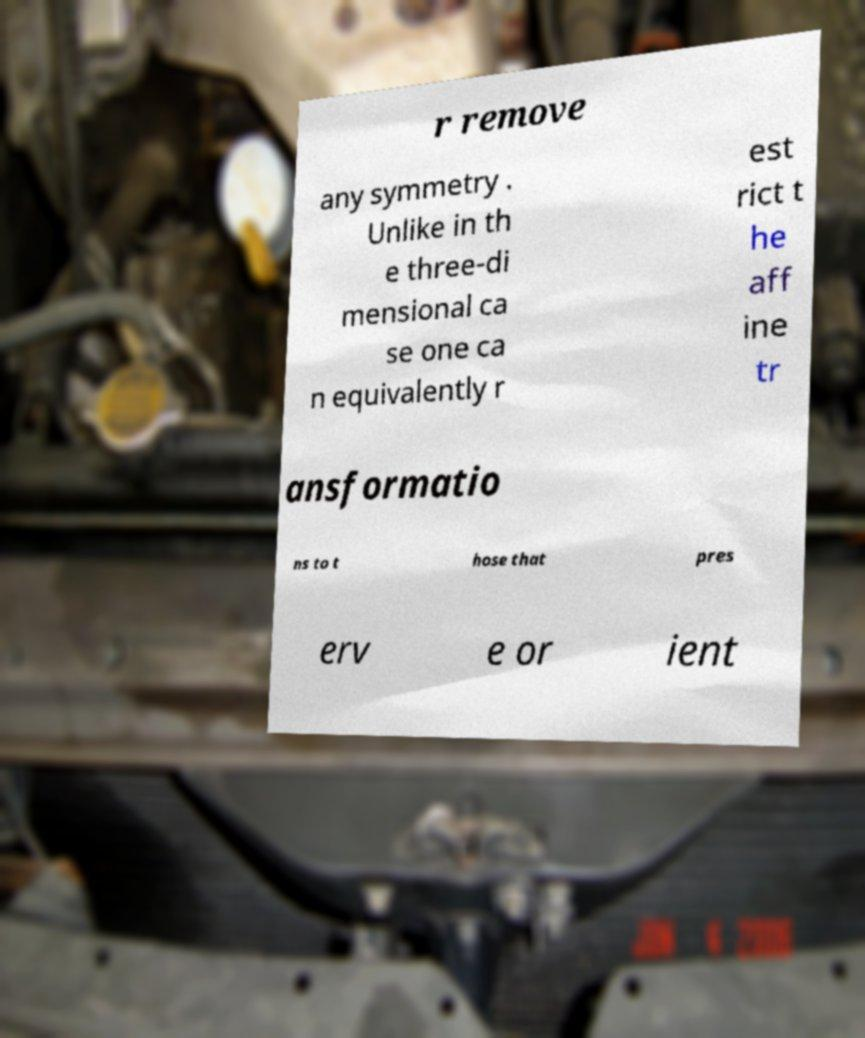Can you accurately transcribe the text from the provided image for me? r remove any symmetry . Unlike in th e three-di mensional ca se one ca n equivalently r est rict t he aff ine tr ansformatio ns to t hose that pres erv e or ient 